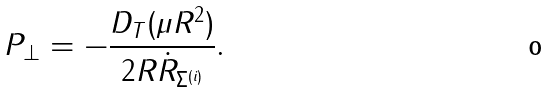<formula> <loc_0><loc_0><loc_500><loc_500>P _ { \perp } = - \frac { D _ { T } ( \mu R ^ { 2 } ) } { 2 R \dot { R } _ { \Sigma ^ { ( i ) } } } .</formula> 